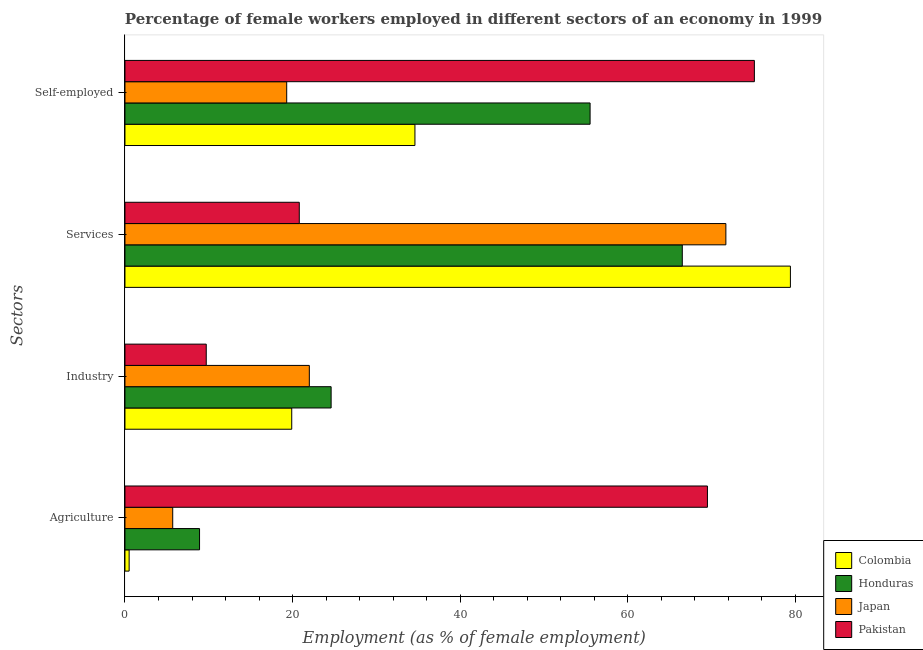Are the number of bars per tick equal to the number of legend labels?
Keep it short and to the point. Yes. Are the number of bars on each tick of the Y-axis equal?
Ensure brevity in your answer.  Yes. How many bars are there on the 2nd tick from the top?
Your answer should be compact. 4. What is the label of the 2nd group of bars from the top?
Your answer should be very brief. Services. What is the percentage of self employed female workers in Honduras?
Your answer should be compact. 55.5. Across all countries, what is the maximum percentage of self employed female workers?
Your response must be concise. 75.1. Across all countries, what is the minimum percentage of female workers in services?
Ensure brevity in your answer.  20.8. In which country was the percentage of female workers in industry maximum?
Offer a terse response. Honduras. In which country was the percentage of female workers in services minimum?
Your response must be concise. Pakistan. What is the total percentage of female workers in industry in the graph?
Offer a very short reply. 76.2. What is the difference between the percentage of female workers in services in Colombia and that in Japan?
Your response must be concise. 7.7. What is the difference between the percentage of female workers in agriculture in Pakistan and the percentage of female workers in services in Japan?
Provide a short and direct response. -2.2. What is the average percentage of self employed female workers per country?
Your answer should be very brief. 46.12. What is the difference between the percentage of self employed female workers and percentage of female workers in agriculture in Colombia?
Give a very brief answer. 34.1. What is the ratio of the percentage of female workers in agriculture in Colombia to that in Honduras?
Provide a succinct answer. 0.06. Is the percentage of female workers in services in Colombia less than that in Japan?
Ensure brevity in your answer.  No. What is the difference between the highest and the second highest percentage of female workers in industry?
Make the answer very short. 2.6. What is the difference between the highest and the lowest percentage of self employed female workers?
Keep it short and to the point. 55.8. What does the 3rd bar from the top in Services represents?
Offer a terse response. Honduras. What does the 2nd bar from the bottom in Agriculture represents?
Give a very brief answer. Honduras. How many bars are there?
Keep it short and to the point. 16. How many countries are there in the graph?
Provide a short and direct response. 4. Are the values on the major ticks of X-axis written in scientific E-notation?
Offer a very short reply. No. Does the graph contain any zero values?
Make the answer very short. No. What is the title of the graph?
Ensure brevity in your answer.  Percentage of female workers employed in different sectors of an economy in 1999. What is the label or title of the X-axis?
Make the answer very short. Employment (as % of female employment). What is the label or title of the Y-axis?
Your response must be concise. Sectors. What is the Employment (as % of female employment) of Colombia in Agriculture?
Make the answer very short. 0.5. What is the Employment (as % of female employment) in Honduras in Agriculture?
Provide a short and direct response. 8.9. What is the Employment (as % of female employment) of Japan in Agriculture?
Provide a succinct answer. 5.7. What is the Employment (as % of female employment) in Pakistan in Agriculture?
Ensure brevity in your answer.  69.5. What is the Employment (as % of female employment) of Colombia in Industry?
Your response must be concise. 19.9. What is the Employment (as % of female employment) in Honduras in Industry?
Provide a succinct answer. 24.6. What is the Employment (as % of female employment) in Japan in Industry?
Make the answer very short. 22. What is the Employment (as % of female employment) in Pakistan in Industry?
Your answer should be very brief. 9.7. What is the Employment (as % of female employment) of Colombia in Services?
Provide a short and direct response. 79.4. What is the Employment (as % of female employment) in Honduras in Services?
Keep it short and to the point. 66.5. What is the Employment (as % of female employment) of Japan in Services?
Provide a short and direct response. 71.7. What is the Employment (as % of female employment) of Pakistan in Services?
Make the answer very short. 20.8. What is the Employment (as % of female employment) in Colombia in Self-employed?
Your response must be concise. 34.6. What is the Employment (as % of female employment) in Honduras in Self-employed?
Provide a short and direct response. 55.5. What is the Employment (as % of female employment) of Japan in Self-employed?
Provide a succinct answer. 19.3. What is the Employment (as % of female employment) of Pakistan in Self-employed?
Your answer should be compact. 75.1. Across all Sectors, what is the maximum Employment (as % of female employment) in Colombia?
Make the answer very short. 79.4. Across all Sectors, what is the maximum Employment (as % of female employment) of Honduras?
Provide a short and direct response. 66.5. Across all Sectors, what is the maximum Employment (as % of female employment) of Japan?
Give a very brief answer. 71.7. Across all Sectors, what is the maximum Employment (as % of female employment) in Pakistan?
Make the answer very short. 75.1. Across all Sectors, what is the minimum Employment (as % of female employment) of Colombia?
Your answer should be very brief. 0.5. Across all Sectors, what is the minimum Employment (as % of female employment) in Honduras?
Make the answer very short. 8.9. Across all Sectors, what is the minimum Employment (as % of female employment) of Japan?
Give a very brief answer. 5.7. Across all Sectors, what is the minimum Employment (as % of female employment) of Pakistan?
Give a very brief answer. 9.7. What is the total Employment (as % of female employment) of Colombia in the graph?
Keep it short and to the point. 134.4. What is the total Employment (as % of female employment) in Honduras in the graph?
Offer a very short reply. 155.5. What is the total Employment (as % of female employment) of Japan in the graph?
Your response must be concise. 118.7. What is the total Employment (as % of female employment) of Pakistan in the graph?
Provide a short and direct response. 175.1. What is the difference between the Employment (as % of female employment) of Colombia in Agriculture and that in Industry?
Your answer should be compact. -19.4. What is the difference between the Employment (as % of female employment) of Honduras in Agriculture and that in Industry?
Your response must be concise. -15.7. What is the difference between the Employment (as % of female employment) of Japan in Agriculture and that in Industry?
Your answer should be compact. -16.3. What is the difference between the Employment (as % of female employment) of Pakistan in Agriculture and that in Industry?
Your answer should be compact. 59.8. What is the difference between the Employment (as % of female employment) of Colombia in Agriculture and that in Services?
Give a very brief answer. -78.9. What is the difference between the Employment (as % of female employment) in Honduras in Agriculture and that in Services?
Offer a terse response. -57.6. What is the difference between the Employment (as % of female employment) in Japan in Agriculture and that in Services?
Ensure brevity in your answer.  -66. What is the difference between the Employment (as % of female employment) of Pakistan in Agriculture and that in Services?
Make the answer very short. 48.7. What is the difference between the Employment (as % of female employment) of Colombia in Agriculture and that in Self-employed?
Your response must be concise. -34.1. What is the difference between the Employment (as % of female employment) in Honduras in Agriculture and that in Self-employed?
Keep it short and to the point. -46.6. What is the difference between the Employment (as % of female employment) in Japan in Agriculture and that in Self-employed?
Keep it short and to the point. -13.6. What is the difference between the Employment (as % of female employment) in Colombia in Industry and that in Services?
Provide a short and direct response. -59.5. What is the difference between the Employment (as % of female employment) in Honduras in Industry and that in Services?
Give a very brief answer. -41.9. What is the difference between the Employment (as % of female employment) of Japan in Industry and that in Services?
Ensure brevity in your answer.  -49.7. What is the difference between the Employment (as % of female employment) in Colombia in Industry and that in Self-employed?
Your answer should be compact. -14.7. What is the difference between the Employment (as % of female employment) of Honduras in Industry and that in Self-employed?
Offer a very short reply. -30.9. What is the difference between the Employment (as % of female employment) of Japan in Industry and that in Self-employed?
Give a very brief answer. 2.7. What is the difference between the Employment (as % of female employment) in Pakistan in Industry and that in Self-employed?
Your answer should be very brief. -65.4. What is the difference between the Employment (as % of female employment) in Colombia in Services and that in Self-employed?
Offer a terse response. 44.8. What is the difference between the Employment (as % of female employment) in Japan in Services and that in Self-employed?
Your response must be concise. 52.4. What is the difference between the Employment (as % of female employment) in Pakistan in Services and that in Self-employed?
Your answer should be very brief. -54.3. What is the difference between the Employment (as % of female employment) in Colombia in Agriculture and the Employment (as % of female employment) in Honduras in Industry?
Make the answer very short. -24.1. What is the difference between the Employment (as % of female employment) in Colombia in Agriculture and the Employment (as % of female employment) in Japan in Industry?
Your answer should be compact. -21.5. What is the difference between the Employment (as % of female employment) in Colombia in Agriculture and the Employment (as % of female employment) in Pakistan in Industry?
Your answer should be compact. -9.2. What is the difference between the Employment (as % of female employment) in Honduras in Agriculture and the Employment (as % of female employment) in Japan in Industry?
Your response must be concise. -13.1. What is the difference between the Employment (as % of female employment) in Colombia in Agriculture and the Employment (as % of female employment) in Honduras in Services?
Make the answer very short. -66. What is the difference between the Employment (as % of female employment) of Colombia in Agriculture and the Employment (as % of female employment) of Japan in Services?
Make the answer very short. -71.2. What is the difference between the Employment (as % of female employment) in Colombia in Agriculture and the Employment (as % of female employment) in Pakistan in Services?
Provide a short and direct response. -20.3. What is the difference between the Employment (as % of female employment) of Honduras in Agriculture and the Employment (as % of female employment) of Japan in Services?
Your response must be concise. -62.8. What is the difference between the Employment (as % of female employment) of Honduras in Agriculture and the Employment (as % of female employment) of Pakistan in Services?
Ensure brevity in your answer.  -11.9. What is the difference between the Employment (as % of female employment) in Japan in Agriculture and the Employment (as % of female employment) in Pakistan in Services?
Provide a succinct answer. -15.1. What is the difference between the Employment (as % of female employment) in Colombia in Agriculture and the Employment (as % of female employment) in Honduras in Self-employed?
Provide a short and direct response. -55. What is the difference between the Employment (as % of female employment) in Colombia in Agriculture and the Employment (as % of female employment) in Japan in Self-employed?
Offer a terse response. -18.8. What is the difference between the Employment (as % of female employment) of Colombia in Agriculture and the Employment (as % of female employment) of Pakistan in Self-employed?
Your answer should be very brief. -74.6. What is the difference between the Employment (as % of female employment) of Honduras in Agriculture and the Employment (as % of female employment) of Pakistan in Self-employed?
Provide a short and direct response. -66.2. What is the difference between the Employment (as % of female employment) in Japan in Agriculture and the Employment (as % of female employment) in Pakistan in Self-employed?
Offer a terse response. -69.4. What is the difference between the Employment (as % of female employment) in Colombia in Industry and the Employment (as % of female employment) in Honduras in Services?
Give a very brief answer. -46.6. What is the difference between the Employment (as % of female employment) in Colombia in Industry and the Employment (as % of female employment) in Japan in Services?
Give a very brief answer. -51.8. What is the difference between the Employment (as % of female employment) of Colombia in Industry and the Employment (as % of female employment) of Pakistan in Services?
Your answer should be very brief. -0.9. What is the difference between the Employment (as % of female employment) in Honduras in Industry and the Employment (as % of female employment) in Japan in Services?
Offer a very short reply. -47.1. What is the difference between the Employment (as % of female employment) of Honduras in Industry and the Employment (as % of female employment) of Pakistan in Services?
Provide a short and direct response. 3.8. What is the difference between the Employment (as % of female employment) in Japan in Industry and the Employment (as % of female employment) in Pakistan in Services?
Offer a very short reply. 1.2. What is the difference between the Employment (as % of female employment) in Colombia in Industry and the Employment (as % of female employment) in Honduras in Self-employed?
Provide a short and direct response. -35.6. What is the difference between the Employment (as % of female employment) of Colombia in Industry and the Employment (as % of female employment) of Japan in Self-employed?
Offer a very short reply. 0.6. What is the difference between the Employment (as % of female employment) in Colombia in Industry and the Employment (as % of female employment) in Pakistan in Self-employed?
Offer a very short reply. -55.2. What is the difference between the Employment (as % of female employment) in Honduras in Industry and the Employment (as % of female employment) in Pakistan in Self-employed?
Give a very brief answer. -50.5. What is the difference between the Employment (as % of female employment) in Japan in Industry and the Employment (as % of female employment) in Pakistan in Self-employed?
Your response must be concise. -53.1. What is the difference between the Employment (as % of female employment) of Colombia in Services and the Employment (as % of female employment) of Honduras in Self-employed?
Give a very brief answer. 23.9. What is the difference between the Employment (as % of female employment) in Colombia in Services and the Employment (as % of female employment) in Japan in Self-employed?
Ensure brevity in your answer.  60.1. What is the difference between the Employment (as % of female employment) in Colombia in Services and the Employment (as % of female employment) in Pakistan in Self-employed?
Offer a very short reply. 4.3. What is the difference between the Employment (as % of female employment) of Honduras in Services and the Employment (as % of female employment) of Japan in Self-employed?
Offer a terse response. 47.2. What is the difference between the Employment (as % of female employment) of Honduras in Services and the Employment (as % of female employment) of Pakistan in Self-employed?
Offer a terse response. -8.6. What is the average Employment (as % of female employment) of Colombia per Sectors?
Keep it short and to the point. 33.6. What is the average Employment (as % of female employment) of Honduras per Sectors?
Your answer should be very brief. 38.88. What is the average Employment (as % of female employment) of Japan per Sectors?
Your response must be concise. 29.68. What is the average Employment (as % of female employment) in Pakistan per Sectors?
Keep it short and to the point. 43.77. What is the difference between the Employment (as % of female employment) in Colombia and Employment (as % of female employment) in Honduras in Agriculture?
Offer a very short reply. -8.4. What is the difference between the Employment (as % of female employment) in Colombia and Employment (as % of female employment) in Pakistan in Agriculture?
Make the answer very short. -69. What is the difference between the Employment (as % of female employment) in Honduras and Employment (as % of female employment) in Japan in Agriculture?
Your answer should be compact. 3.2. What is the difference between the Employment (as % of female employment) of Honduras and Employment (as % of female employment) of Pakistan in Agriculture?
Your answer should be compact. -60.6. What is the difference between the Employment (as % of female employment) in Japan and Employment (as % of female employment) in Pakistan in Agriculture?
Make the answer very short. -63.8. What is the difference between the Employment (as % of female employment) of Colombia and Employment (as % of female employment) of Japan in Industry?
Provide a short and direct response. -2.1. What is the difference between the Employment (as % of female employment) in Colombia and Employment (as % of female employment) in Pakistan in Industry?
Your answer should be compact. 10.2. What is the difference between the Employment (as % of female employment) of Honduras and Employment (as % of female employment) of Japan in Industry?
Offer a very short reply. 2.6. What is the difference between the Employment (as % of female employment) in Japan and Employment (as % of female employment) in Pakistan in Industry?
Offer a terse response. 12.3. What is the difference between the Employment (as % of female employment) of Colombia and Employment (as % of female employment) of Pakistan in Services?
Make the answer very short. 58.6. What is the difference between the Employment (as % of female employment) in Honduras and Employment (as % of female employment) in Japan in Services?
Provide a succinct answer. -5.2. What is the difference between the Employment (as % of female employment) in Honduras and Employment (as % of female employment) in Pakistan in Services?
Your response must be concise. 45.7. What is the difference between the Employment (as % of female employment) of Japan and Employment (as % of female employment) of Pakistan in Services?
Your response must be concise. 50.9. What is the difference between the Employment (as % of female employment) of Colombia and Employment (as % of female employment) of Honduras in Self-employed?
Your answer should be compact. -20.9. What is the difference between the Employment (as % of female employment) of Colombia and Employment (as % of female employment) of Pakistan in Self-employed?
Offer a very short reply. -40.5. What is the difference between the Employment (as % of female employment) of Honduras and Employment (as % of female employment) of Japan in Self-employed?
Make the answer very short. 36.2. What is the difference between the Employment (as % of female employment) of Honduras and Employment (as % of female employment) of Pakistan in Self-employed?
Your answer should be compact. -19.6. What is the difference between the Employment (as % of female employment) in Japan and Employment (as % of female employment) in Pakistan in Self-employed?
Ensure brevity in your answer.  -55.8. What is the ratio of the Employment (as % of female employment) of Colombia in Agriculture to that in Industry?
Give a very brief answer. 0.03. What is the ratio of the Employment (as % of female employment) of Honduras in Agriculture to that in Industry?
Offer a very short reply. 0.36. What is the ratio of the Employment (as % of female employment) of Japan in Agriculture to that in Industry?
Offer a terse response. 0.26. What is the ratio of the Employment (as % of female employment) in Pakistan in Agriculture to that in Industry?
Your answer should be very brief. 7.16. What is the ratio of the Employment (as % of female employment) in Colombia in Agriculture to that in Services?
Your answer should be very brief. 0.01. What is the ratio of the Employment (as % of female employment) in Honduras in Agriculture to that in Services?
Make the answer very short. 0.13. What is the ratio of the Employment (as % of female employment) of Japan in Agriculture to that in Services?
Keep it short and to the point. 0.08. What is the ratio of the Employment (as % of female employment) in Pakistan in Agriculture to that in Services?
Give a very brief answer. 3.34. What is the ratio of the Employment (as % of female employment) in Colombia in Agriculture to that in Self-employed?
Your answer should be compact. 0.01. What is the ratio of the Employment (as % of female employment) in Honduras in Agriculture to that in Self-employed?
Keep it short and to the point. 0.16. What is the ratio of the Employment (as % of female employment) of Japan in Agriculture to that in Self-employed?
Provide a short and direct response. 0.3. What is the ratio of the Employment (as % of female employment) of Pakistan in Agriculture to that in Self-employed?
Keep it short and to the point. 0.93. What is the ratio of the Employment (as % of female employment) in Colombia in Industry to that in Services?
Your response must be concise. 0.25. What is the ratio of the Employment (as % of female employment) of Honduras in Industry to that in Services?
Provide a short and direct response. 0.37. What is the ratio of the Employment (as % of female employment) in Japan in Industry to that in Services?
Give a very brief answer. 0.31. What is the ratio of the Employment (as % of female employment) in Pakistan in Industry to that in Services?
Make the answer very short. 0.47. What is the ratio of the Employment (as % of female employment) in Colombia in Industry to that in Self-employed?
Keep it short and to the point. 0.58. What is the ratio of the Employment (as % of female employment) of Honduras in Industry to that in Self-employed?
Provide a short and direct response. 0.44. What is the ratio of the Employment (as % of female employment) of Japan in Industry to that in Self-employed?
Ensure brevity in your answer.  1.14. What is the ratio of the Employment (as % of female employment) in Pakistan in Industry to that in Self-employed?
Your response must be concise. 0.13. What is the ratio of the Employment (as % of female employment) in Colombia in Services to that in Self-employed?
Provide a succinct answer. 2.29. What is the ratio of the Employment (as % of female employment) of Honduras in Services to that in Self-employed?
Ensure brevity in your answer.  1.2. What is the ratio of the Employment (as % of female employment) in Japan in Services to that in Self-employed?
Give a very brief answer. 3.71. What is the ratio of the Employment (as % of female employment) in Pakistan in Services to that in Self-employed?
Your answer should be very brief. 0.28. What is the difference between the highest and the second highest Employment (as % of female employment) in Colombia?
Give a very brief answer. 44.8. What is the difference between the highest and the second highest Employment (as % of female employment) of Japan?
Offer a terse response. 49.7. What is the difference between the highest and the lowest Employment (as % of female employment) of Colombia?
Provide a short and direct response. 78.9. What is the difference between the highest and the lowest Employment (as % of female employment) of Honduras?
Keep it short and to the point. 57.6. What is the difference between the highest and the lowest Employment (as % of female employment) in Pakistan?
Keep it short and to the point. 65.4. 